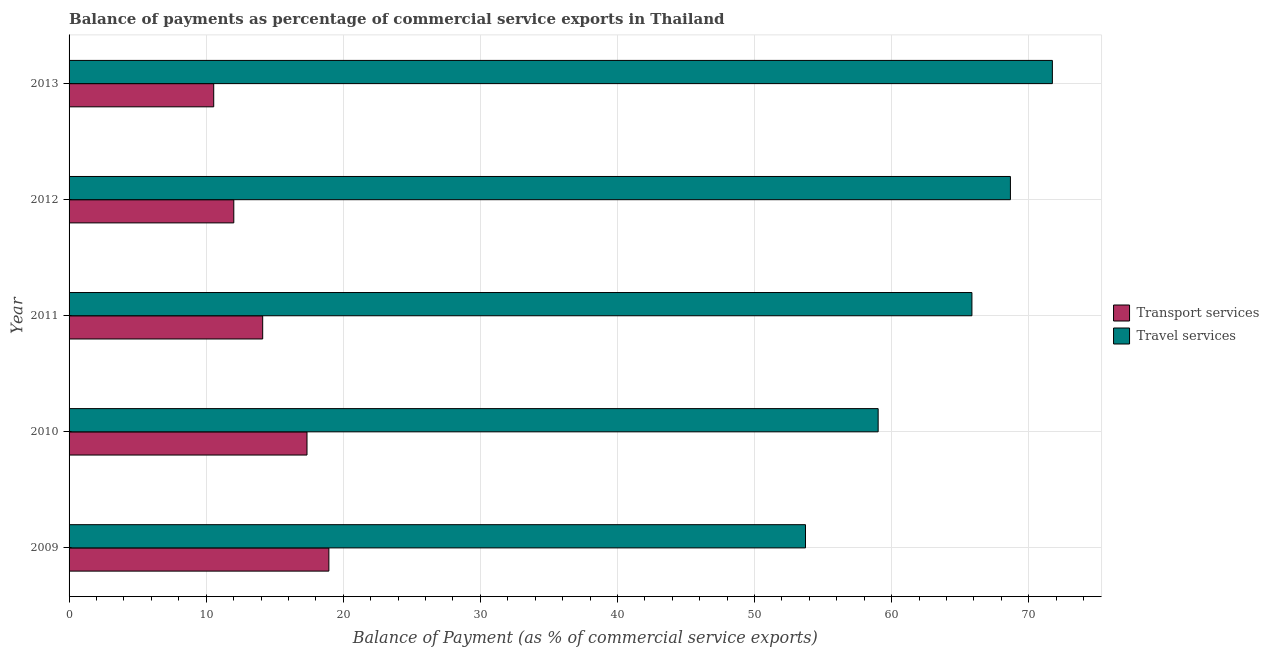How many different coloured bars are there?
Offer a terse response. 2. How many groups of bars are there?
Your answer should be very brief. 5. How many bars are there on the 4th tick from the top?
Keep it short and to the point. 2. How many bars are there on the 1st tick from the bottom?
Keep it short and to the point. 2. What is the label of the 4th group of bars from the top?
Your answer should be compact. 2010. In how many cases, is the number of bars for a given year not equal to the number of legend labels?
Give a very brief answer. 0. What is the balance of payments of transport services in 2009?
Your response must be concise. 18.95. Across all years, what is the maximum balance of payments of transport services?
Offer a terse response. 18.95. Across all years, what is the minimum balance of payments of transport services?
Give a very brief answer. 10.55. In which year was the balance of payments of transport services maximum?
Make the answer very short. 2009. What is the total balance of payments of transport services in the graph?
Your answer should be compact. 73. What is the difference between the balance of payments of travel services in 2012 and that in 2013?
Provide a succinct answer. -3.06. What is the difference between the balance of payments of travel services in 2012 and the balance of payments of transport services in 2013?
Your response must be concise. 58.11. What is the average balance of payments of transport services per year?
Your answer should be very brief. 14.6. In the year 2009, what is the difference between the balance of payments of transport services and balance of payments of travel services?
Make the answer very short. -34.77. In how many years, is the balance of payments of travel services greater than 56 %?
Give a very brief answer. 4. What is the ratio of the balance of payments of travel services in 2009 to that in 2012?
Your answer should be very brief. 0.78. Is the balance of payments of transport services in 2012 less than that in 2013?
Offer a very short reply. No. Is the difference between the balance of payments of travel services in 2009 and 2011 greater than the difference between the balance of payments of transport services in 2009 and 2011?
Ensure brevity in your answer.  No. What is the difference between the highest and the second highest balance of payments of travel services?
Offer a very short reply. 3.06. What is the difference between the highest and the lowest balance of payments of travel services?
Provide a short and direct response. 18.01. What does the 1st bar from the top in 2010 represents?
Give a very brief answer. Travel services. What does the 1st bar from the bottom in 2011 represents?
Keep it short and to the point. Transport services. Are all the bars in the graph horizontal?
Your answer should be very brief. Yes. What is the difference between two consecutive major ticks on the X-axis?
Provide a succinct answer. 10. Does the graph contain any zero values?
Provide a succinct answer. No. How are the legend labels stacked?
Provide a succinct answer. Vertical. What is the title of the graph?
Provide a succinct answer. Balance of payments as percentage of commercial service exports in Thailand. What is the label or title of the X-axis?
Provide a short and direct response. Balance of Payment (as % of commercial service exports). What is the Balance of Payment (as % of commercial service exports) in Transport services in 2009?
Provide a succinct answer. 18.95. What is the Balance of Payment (as % of commercial service exports) of Travel services in 2009?
Provide a succinct answer. 53.72. What is the Balance of Payment (as % of commercial service exports) of Transport services in 2010?
Provide a short and direct response. 17.36. What is the Balance of Payment (as % of commercial service exports) of Travel services in 2010?
Your answer should be compact. 59.02. What is the Balance of Payment (as % of commercial service exports) of Transport services in 2011?
Offer a very short reply. 14.12. What is the Balance of Payment (as % of commercial service exports) in Travel services in 2011?
Your answer should be compact. 65.86. What is the Balance of Payment (as % of commercial service exports) of Transport services in 2012?
Your response must be concise. 12.02. What is the Balance of Payment (as % of commercial service exports) of Travel services in 2012?
Provide a short and direct response. 68.66. What is the Balance of Payment (as % of commercial service exports) in Transport services in 2013?
Your answer should be compact. 10.55. What is the Balance of Payment (as % of commercial service exports) of Travel services in 2013?
Your answer should be compact. 71.72. Across all years, what is the maximum Balance of Payment (as % of commercial service exports) in Transport services?
Your response must be concise. 18.95. Across all years, what is the maximum Balance of Payment (as % of commercial service exports) in Travel services?
Your answer should be compact. 71.72. Across all years, what is the minimum Balance of Payment (as % of commercial service exports) of Transport services?
Give a very brief answer. 10.55. Across all years, what is the minimum Balance of Payment (as % of commercial service exports) of Travel services?
Offer a terse response. 53.72. What is the total Balance of Payment (as % of commercial service exports) in Transport services in the graph?
Keep it short and to the point. 73. What is the total Balance of Payment (as % of commercial service exports) in Travel services in the graph?
Provide a short and direct response. 318.98. What is the difference between the Balance of Payment (as % of commercial service exports) of Transport services in 2009 and that in 2010?
Give a very brief answer. 1.6. What is the difference between the Balance of Payment (as % of commercial service exports) in Travel services in 2009 and that in 2010?
Your response must be concise. -5.3. What is the difference between the Balance of Payment (as % of commercial service exports) in Transport services in 2009 and that in 2011?
Ensure brevity in your answer.  4.83. What is the difference between the Balance of Payment (as % of commercial service exports) of Travel services in 2009 and that in 2011?
Make the answer very short. -12.14. What is the difference between the Balance of Payment (as % of commercial service exports) in Transport services in 2009 and that in 2012?
Your answer should be compact. 6.94. What is the difference between the Balance of Payment (as % of commercial service exports) of Travel services in 2009 and that in 2012?
Provide a short and direct response. -14.95. What is the difference between the Balance of Payment (as % of commercial service exports) of Transport services in 2009 and that in 2013?
Your answer should be very brief. 8.4. What is the difference between the Balance of Payment (as % of commercial service exports) in Travel services in 2009 and that in 2013?
Your answer should be compact. -18.01. What is the difference between the Balance of Payment (as % of commercial service exports) of Transport services in 2010 and that in 2011?
Make the answer very short. 3.23. What is the difference between the Balance of Payment (as % of commercial service exports) in Travel services in 2010 and that in 2011?
Your answer should be compact. -6.84. What is the difference between the Balance of Payment (as % of commercial service exports) in Transport services in 2010 and that in 2012?
Offer a very short reply. 5.34. What is the difference between the Balance of Payment (as % of commercial service exports) of Travel services in 2010 and that in 2012?
Provide a short and direct response. -9.65. What is the difference between the Balance of Payment (as % of commercial service exports) of Transport services in 2010 and that in 2013?
Your response must be concise. 6.8. What is the difference between the Balance of Payment (as % of commercial service exports) of Travel services in 2010 and that in 2013?
Your answer should be very brief. -12.71. What is the difference between the Balance of Payment (as % of commercial service exports) in Transport services in 2011 and that in 2012?
Your response must be concise. 2.11. What is the difference between the Balance of Payment (as % of commercial service exports) in Travel services in 2011 and that in 2012?
Offer a terse response. -2.81. What is the difference between the Balance of Payment (as % of commercial service exports) of Transport services in 2011 and that in 2013?
Provide a short and direct response. 3.57. What is the difference between the Balance of Payment (as % of commercial service exports) of Travel services in 2011 and that in 2013?
Ensure brevity in your answer.  -5.87. What is the difference between the Balance of Payment (as % of commercial service exports) in Transport services in 2012 and that in 2013?
Your answer should be very brief. 1.46. What is the difference between the Balance of Payment (as % of commercial service exports) in Travel services in 2012 and that in 2013?
Your answer should be compact. -3.06. What is the difference between the Balance of Payment (as % of commercial service exports) of Transport services in 2009 and the Balance of Payment (as % of commercial service exports) of Travel services in 2010?
Offer a terse response. -40.07. What is the difference between the Balance of Payment (as % of commercial service exports) of Transport services in 2009 and the Balance of Payment (as % of commercial service exports) of Travel services in 2011?
Offer a terse response. -46.91. What is the difference between the Balance of Payment (as % of commercial service exports) of Transport services in 2009 and the Balance of Payment (as % of commercial service exports) of Travel services in 2012?
Your answer should be compact. -49.71. What is the difference between the Balance of Payment (as % of commercial service exports) in Transport services in 2009 and the Balance of Payment (as % of commercial service exports) in Travel services in 2013?
Give a very brief answer. -52.77. What is the difference between the Balance of Payment (as % of commercial service exports) in Transport services in 2010 and the Balance of Payment (as % of commercial service exports) in Travel services in 2011?
Provide a succinct answer. -48.5. What is the difference between the Balance of Payment (as % of commercial service exports) of Transport services in 2010 and the Balance of Payment (as % of commercial service exports) of Travel services in 2012?
Offer a very short reply. -51.31. What is the difference between the Balance of Payment (as % of commercial service exports) in Transport services in 2010 and the Balance of Payment (as % of commercial service exports) in Travel services in 2013?
Make the answer very short. -54.37. What is the difference between the Balance of Payment (as % of commercial service exports) of Transport services in 2011 and the Balance of Payment (as % of commercial service exports) of Travel services in 2012?
Provide a short and direct response. -54.54. What is the difference between the Balance of Payment (as % of commercial service exports) of Transport services in 2011 and the Balance of Payment (as % of commercial service exports) of Travel services in 2013?
Your answer should be compact. -57.6. What is the difference between the Balance of Payment (as % of commercial service exports) of Transport services in 2012 and the Balance of Payment (as % of commercial service exports) of Travel services in 2013?
Make the answer very short. -59.71. What is the average Balance of Payment (as % of commercial service exports) of Transport services per year?
Provide a succinct answer. 14.6. What is the average Balance of Payment (as % of commercial service exports) of Travel services per year?
Make the answer very short. 63.8. In the year 2009, what is the difference between the Balance of Payment (as % of commercial service exports) of Transport services and Balance of Payment (as % of commercial service exports) of Travel services?
Keep it short and to the point. -34.77. In the year 2010, what is the difference between the Balance of Payment (as % of commercial service exports) in Transport services and Balance of Payment (as % of commercial service exports) in Travel services?
Give a very brief answer. -41.66. In the year 2011, what is the difference between the Balance of Payment (as % of commercial service exports) of Transport services and Balance of Payment (as % of commercial service exports) of Travel services?
Make the answer very short. -51.73. In the year 2012, what is the difference between the Balance of Payment (as % of commercial service exports) of Transport services and Balance of Payment (as % of commercial service exports) of Travel services?
Offer a very short reply. -56.65. In the year 2013, what is the difference between the Balance of Payment (as % of commercial service exports) in Transport services and Balance of Payment (as % of commercial service exports) in Travel services?
Provide a short and direct response. -61.17. What is the ratio of the Balance of Payment (as % of commercial service exports) in Transport services in 2009 to that in 2010?
Your answer should be compact. 1.09. What is the ratio of the Balance of Payment (as % of commercial service exports) of Travel services in 2009 to that in 2010?
Offer a terse response. 0.91. What is the ratio of the Balance of Payment (as % of commercial service exports) in Transport services in 2009 to that in 2011?
Give a very brief answer. 1.34. What is the ratio of the Balance of Payment (as % of commercial service exports) of Travel services in 2009 to that in 2011?
Your answer should be very brief. 0.82. What is the ratio of the Balance of Payment (as % of commercial service exports) in Transport services in 2009 to that in 2012?
Your answer should be very brief. 1.58. What is the ratio of the Balance of Payment (as % of commercial service exports) of Travel services in 2009 to that in 2012?
Your answer should be compact. 0.78. What is the ratio of the Balance of Payment (as % of commercial service exports) in Transport services in 2009 to that in 2013?
Offer a very short reply. 1.8. What is the ratio of the Balance of Payment (as % of commercial service exports) in Travel services in 2009 to that in 2013?
Make the answer very short. 0.75. What is the ratio of the Balance of Payment (as % of commercial service exports) of Transport services in 2010 to that in 2011?
Offer a terse response. 1.23. What is the ratio of the Balance of Payment (as % of commercial service exports) in Travel services in 2010 to that in 2011?
Ensure brevity in your answer.  0.9. What is the ratio of the Balance of Payment (as % of commercial service exports) in Transport services in 2010 to that in 2012?
Give a very brief answer. 1.44. What is the ratio of the Balance of Payment (as % of commercial service exports) in Travel services in 2010 to that in 2012?
Offer a very short reply. 0.86. What is the ratio of the Balance of Payment (as % of commercial service exports) in Transport services in 2010 to that in 2013?
Your answer should be compact. 1.64. What is the ratio of the Balance of Payment (as % of commercial service exports) of Travel services in 2010 to that in 2013?
Give a very brief answer. 0.82. What is the ratio of the Balance of Payment (as % of commercial service exports) of Transport services in 2011 to that in 2012?
Offer a very short reply. 1.18. What is the ratio of the Balance of Payment (as % of commercial service exports) in Travel services in 2011 to that in 2012?
Offer a very short reply. 0.96. What is the ratio of the Balance of Payment (as % of commercial service exports) in Transport services in 2011 to that in 2013?
Your answer should be very brief. 1.34. What is the ratio of the Balance of Payment (as % of commercial service exports) in Travel services in 2011 to that in 2013?
Offer a terse response. 0.92. What is the ratio of the Balance of Payment (as % of commercial service exports) in Transport services in 2012 to that in 2013?
Offer a very short reply. 1.14. What is the ratio of the Balance of Payment (as % of commercial service exports) in Travel services in 2012 to that in 2013?
Your response must be concise. 0.96. What is the difference between the highest and the second highest Balance of Payment (as % of commercial service exports) of Transport services?
Offer a very short reply. 1.6. What is the difference between the highest and the second highest Balance of Payment (as % of commercial service exports) of Travel services?
Make the answer very short. 3.06. What is the difference between the highest and the lowest Balance of Payment (as % of commercial service exports) in Transport services?
Ensure brevity in your answer.  8.4. What is the difference between the highest and the lowest Balance of Payment (as % of commercial service exports) of Travel services?
Keep it short and to the point. 18.01. 